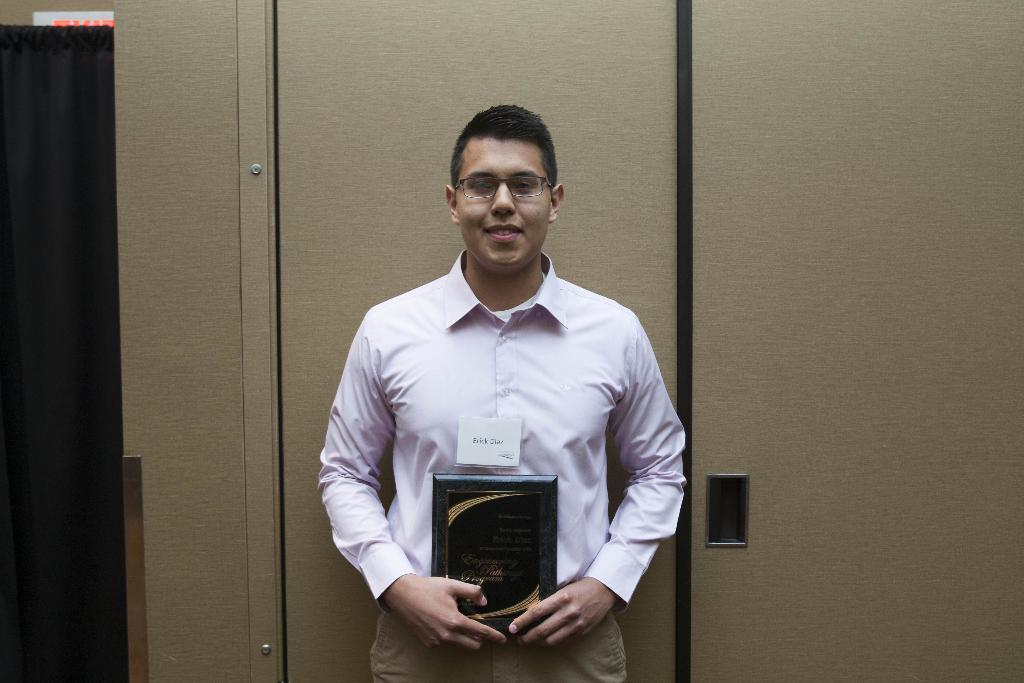What is the man in the image doing? The man is standing in the image. What object is the man holding in his hand? The man is holding a book in his hand. What can be seen in the background of the image? There is a wooden wall in the background of the image. How does the man express his anger in the image? There is no indication of anger in the image; the man is simply standing and holding a book. 